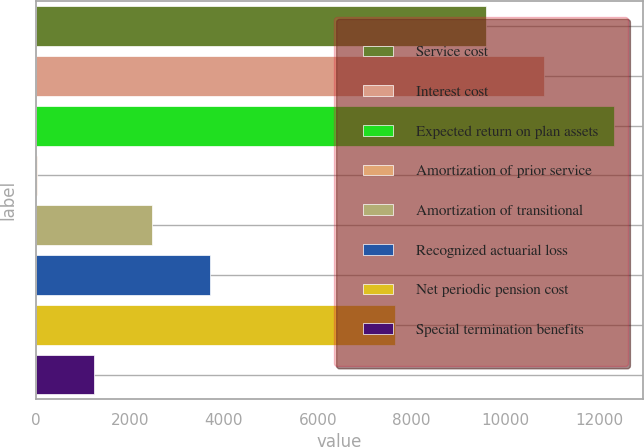Convert chart to OTSL. <chart><loc_0><loc_0><loc_500><loc_500><bar_chart><fcel>Service cost<fcel>Interest cost<fcel>Expected return on plan assets<fcel>Amortization of prior service<fcel>Amortization of transitional<fcel>Recognized actuarial loss<fcel>Net periodic pension cost<fcel>Special termination benefits<nl><fcel>9580<fcel>10810.4<fcel>12312<fcel>8<fcel>2468.8<fcel>3699.2<fcel>7655<fcel>1238.4<nl></chart> 